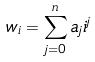Convert formula to latex. <formula><loc_0><loc_0><loc_500><loc_500>w _ { i } = \sum _ { j = 0 } ^ { n } a _ { j } i ^ { j }</formula> 